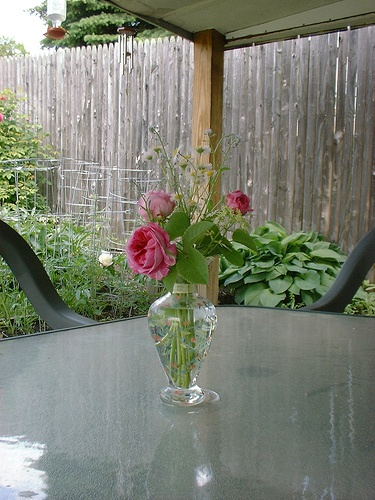Describe the objects in this image and their specific colors. I can see dining table in white, gray, and darkgray tones, vase in white, darkgray, gray, and darkgreen tones, chair in white, black, gray, and darkgreen tones, chair in white, black, gray, and purple tones, and vase in white, darkgreen, darkgray, and gray tones in this image. 